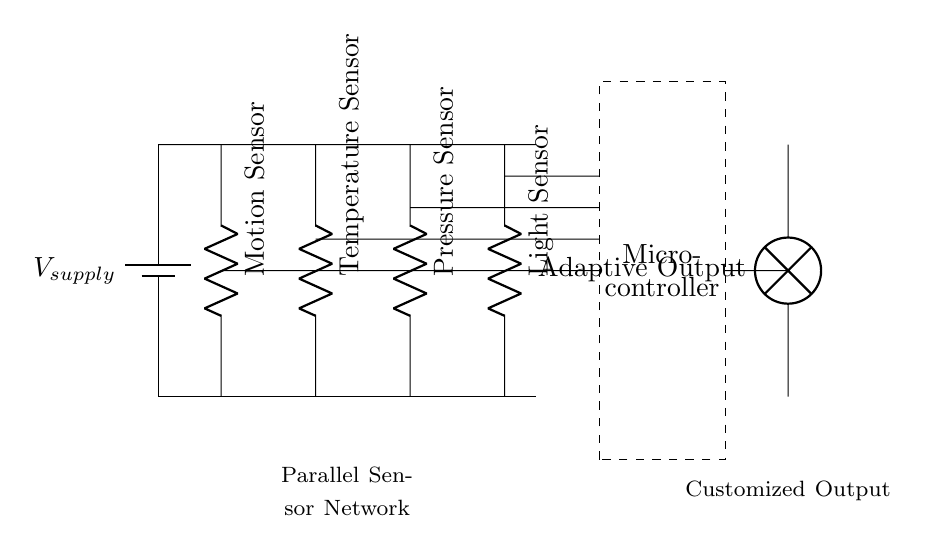What components are connected in parallel? The circuit shows a motion sensor, temperature sensor, pressure sensor, and light sensor connected in parallel, meaning they all share the same voltage supply.
Answer: motion sensor, temperature sensor, pressure sensor, light sensor What is the purpose of the microcontroller? The microcontroller processes signals from the sensors. It receives data from the sensors connected in parallel to make decisions for the adaptive technology device.
Answer: Process signals How many sensors are used in this circuit? There are four sensors shown in the circuit: motion, temperature, pressure, and light sensors, indicating the number of parallel branches.
Answer: Four What type of circuit is this and why? This circuit is a parallel circuit because all sensor components are connected alongside each other, sharing the same voltage supply, which is typical for circuits that need multiple pathways for current flow.
Answer: Parallel What happens if one sensor fails? If one sensor fails in a parallel circuit, the other sensors will still function, as each has its own independent path to the voltage supply. This shows the reliability of parallel circuits.
Answer: Other sensors remain functional What is the output connected to? The output of this circuit is connected to an adaptive output lamp, which likely indicates the combined response or condition determined by the sensors and the microcontroller.
Answer: Adaptive output lamp 